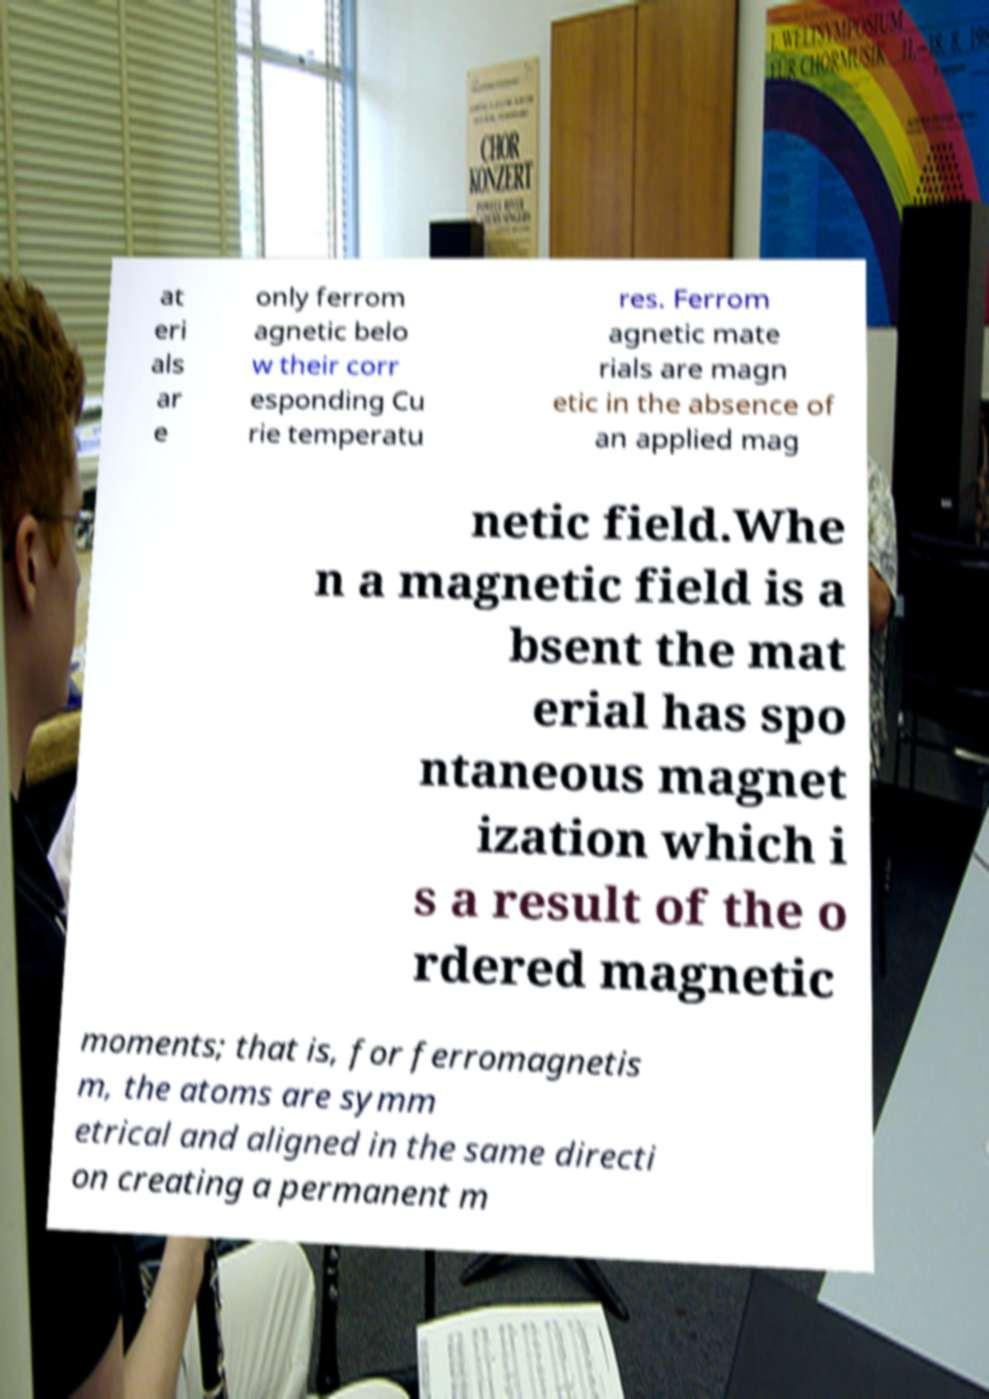For documentation purposes, I need the text within this image transcribed. Could you provide that? at eri als ar e only ferrom agnetic belo w their corr esponding Cu rie temperatu res. Ferrom agnetic mate rials are magn etic in the absence of an applied mag netic field.Whe n a magnetic field is a bsent the mat erial has spo ntaneous magnet ization which i s a result of the o rdered magnetic moments; that is, for ferromagnetis m, the atoms are symm etrical and aligned in the same directi on creating a permanent m 